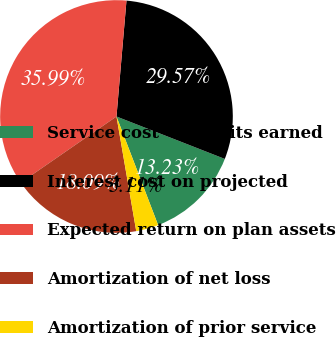Convert chart to OTSL. <chart><loc_0><loc_0><loc_500><loc_500><pie_chart><fcel>Service cost - benefits earned<fcel>Interest cost on projected<fcel>Expected return on plan assets<fcel>Amortization of net loss<fcel>Amortization of prior service<nl><fcel>13.23%<fcel>29.57%<fcel>35.99%<fcel>18.09%<fcel>3.11%<nl></chart> 